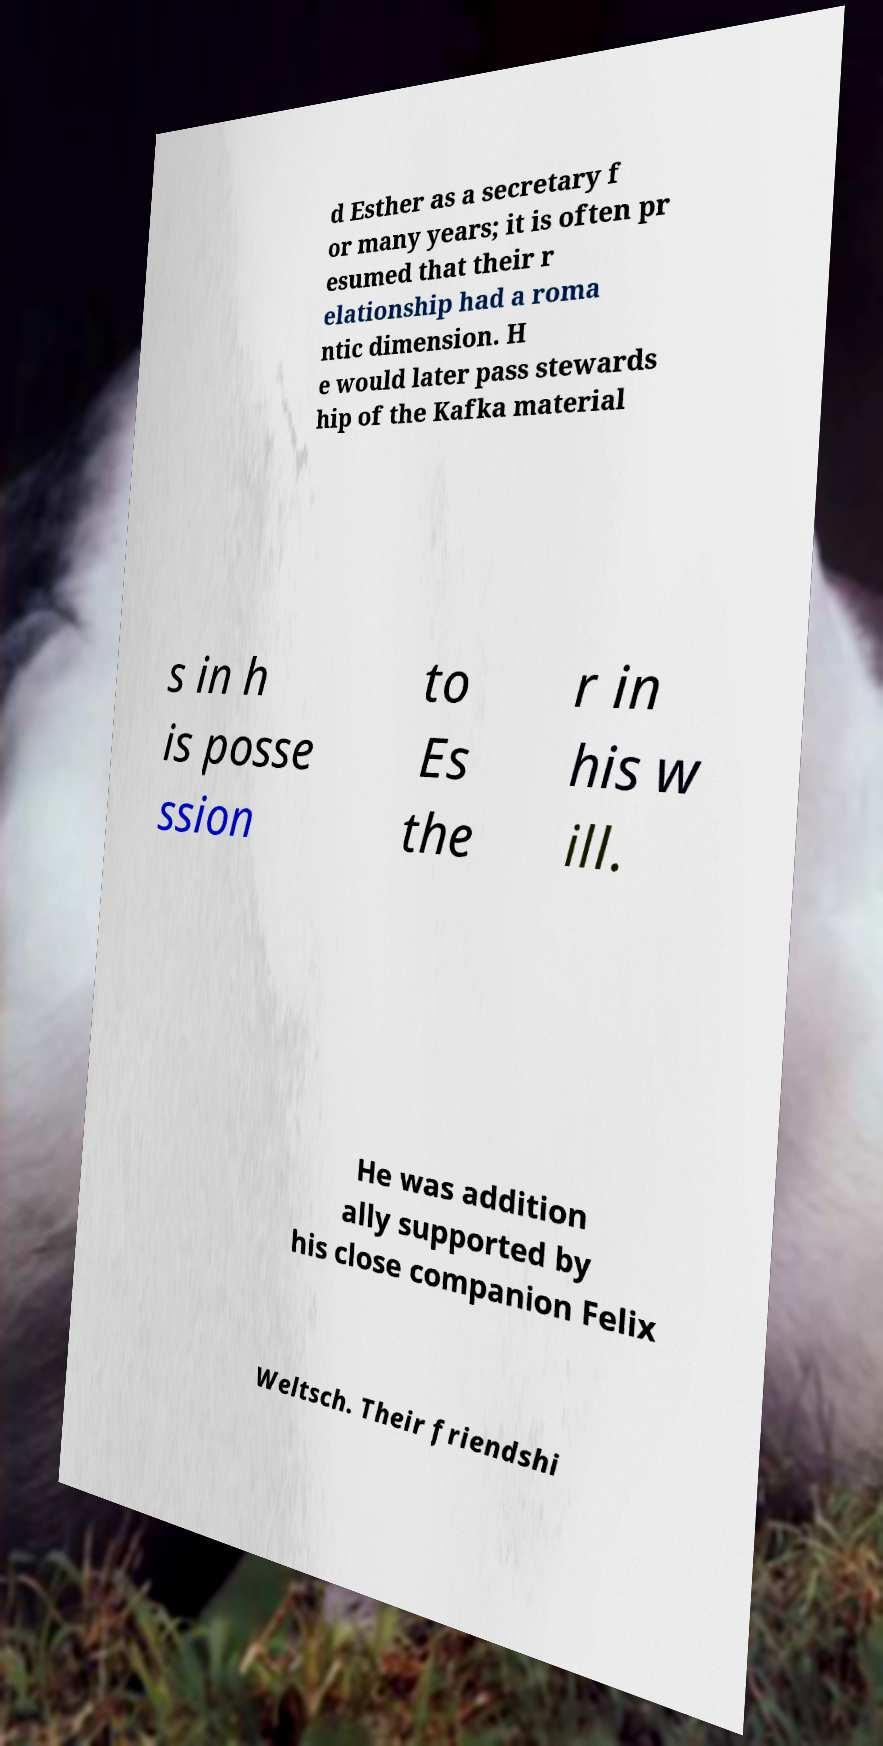For documentation purposes, I need the text within this image transcribed. Could you provide that? d Esther as a secretary f or many years; it is often pr esumed that their r elationship had a roma ntic dimension. H e would later pass stewards hip of the Kafka material s in h is posse ssion to Es the r in his w ill. He was addition ally supported by his close companion Felix Weltsch. Their friendshi 